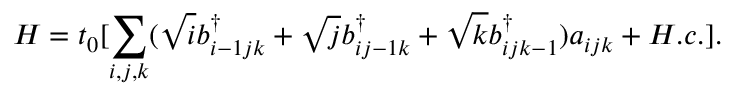Convert formula to latex. <formula><loc_0><loc_0><loc_500><loc_500>H = t _ { 0 } [ \sum _ { i , j , k } ( \sqrt { i } b _ { i - 1 j k } ^ { \dagger } + \sqrt { j } b _ { i j - 1 k } ^ { \dagger } + \sqrt { k } b _ { i j k - 1 } ^ { \dagger } ) a _ { i j k } + H . c . ] .</formula> 